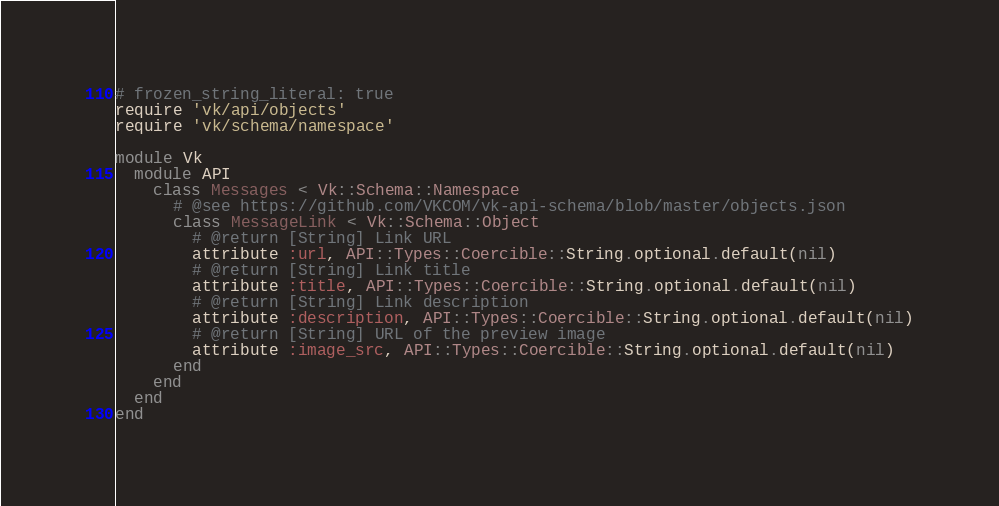<code> <loc_0><loc_0><loc_500><loc_500><_Ruby_># frozen_string_literal: true
require 'vk/api/objects'
require 'vk/schema/namespace'

module Vk
  module API
    class Messages < Vk::Schema::Namespace
      # @see https://github.com/VKCOM/vk-api-schema/blob/master/objects.json
      class MessageLink < Vk::Schema::Object
        # @return [String] Link URL
        attribute :url, API::Types::Coercible::String.optional.default(nil)
        # @return [String] Link title
        attribute :title, API::Types::Coercible::String.optional.default(nil)
        # @return [String] Link description
        attribute :description, API::Types::Coercible::String.optional.default(nil)
        # @return [String] URL of the preview image
        attribute :image_src, API::Types::Coercible::String.optional.default(nil)
      end
    end
  end
end
</code> 